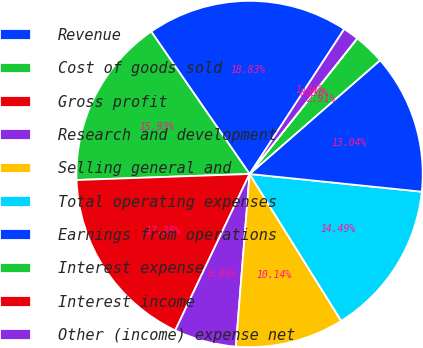Convert chart. <chart><loc_0><loc_0><loc_500><loc_500><pie_chart><fcel>Revenue<fcel>Cost of goods sold<fcel>Gross profit<fcel>Research and development<fcel>Selling general and<fcel>Total operating expenses<fcel>Earnings from operations<fcel>Interest expense<fcel>Interest income<fcel>Other (income) expense net<nl><fcel>18.83%<fcel>15.93%<fcel>17.38%<fcel>5.8%<fcel>10.14%<fcel>14.49%<fcel>13.04%<fcel>2.91%<fcel>0.01%<fcel>1.46%<nl></chart> 